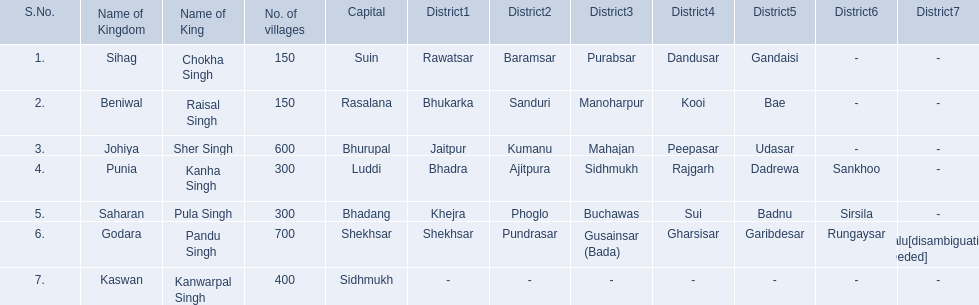What are all of the kingdoms? Sihag, Beniwal, Johiya, Punia, Saharan, Godara, Kaswan. How many villages do they contain? 150, 150, 600, 300, 300, 700, 400. How many are in godara? 700. Which kingdom comes next in highest amount of villages? Johiya. 